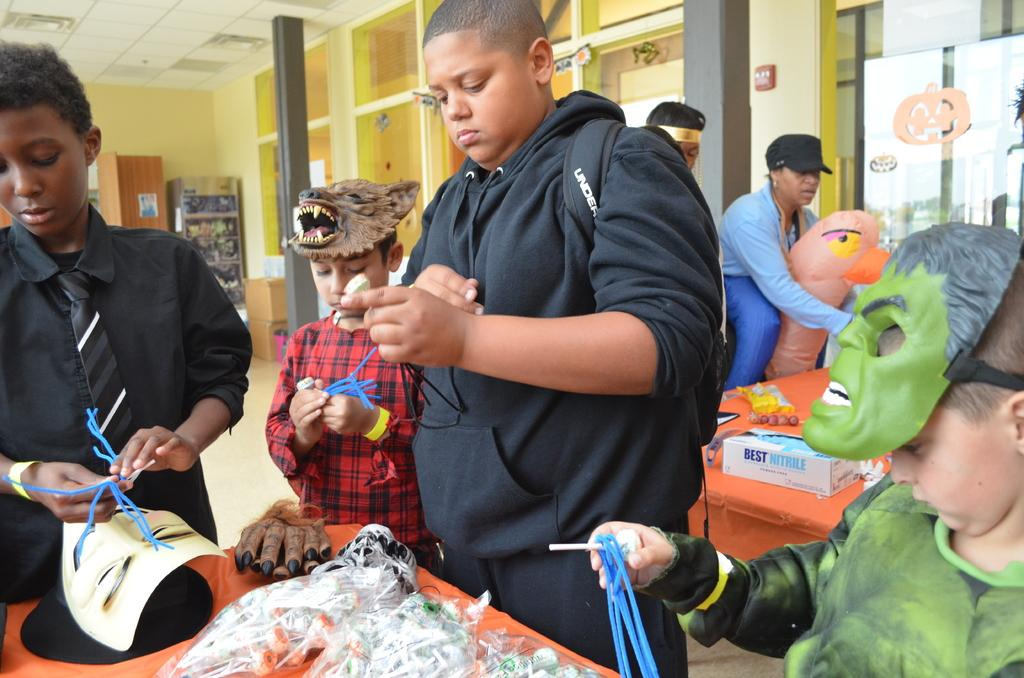What is the main subject in the foreground of the image? There are children in the foreground of the image. Are the children wearing any specific accessories? Some of the children are wearing masks. What type of rifle can be seen in the hands of the children in the image? There is no rifle present in the image; the children are wearing masks. 